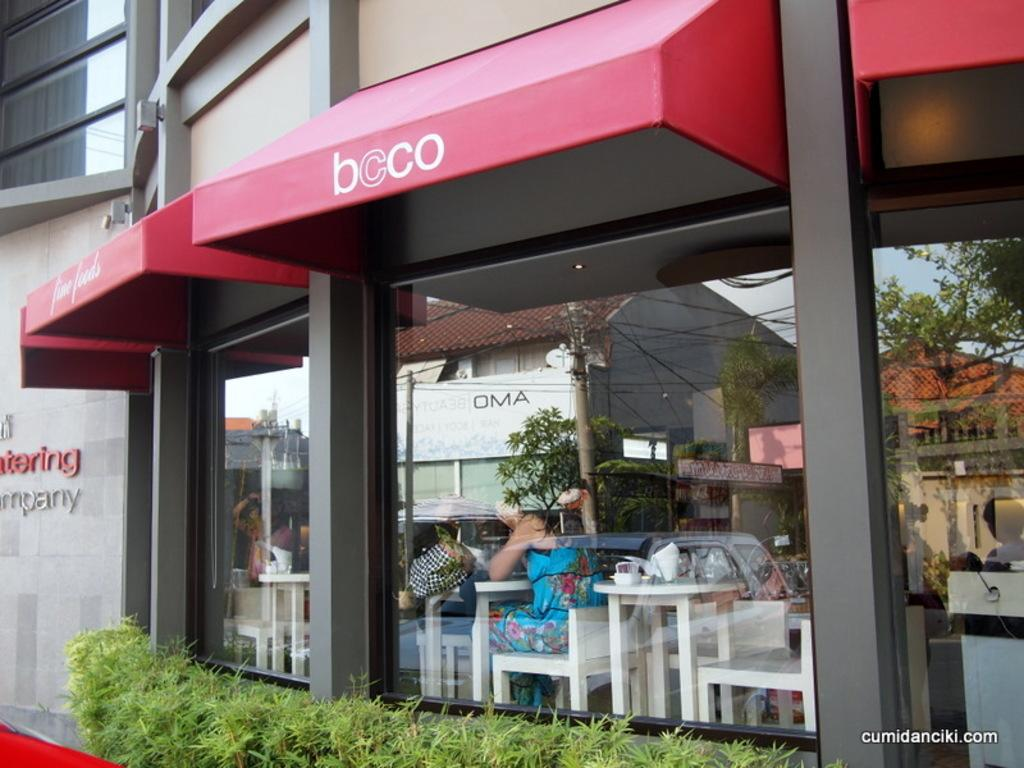What are the people in the image doing? The people in the image are sitting on chairs. What can be found on the table in the image? There are tissues on the table in the image. What can be seen in the background of the image? There are illusions of buildings and trees in the background of the image. What type of hot beverage is being served by the authority figure in the image? There is no authority figure or hot beverage present in the image. 